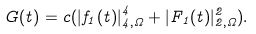<formula> <loc_0><loc_0><loc_500><loc_500>G ( t ) = c ( | f _ { 1 } ( t ) | _ { 4 , \Omega } ^ { 4 } + | F _ { 1 } ( t ) | _ { 2 , \Omega } ^ { 2 } ) .</formula> 